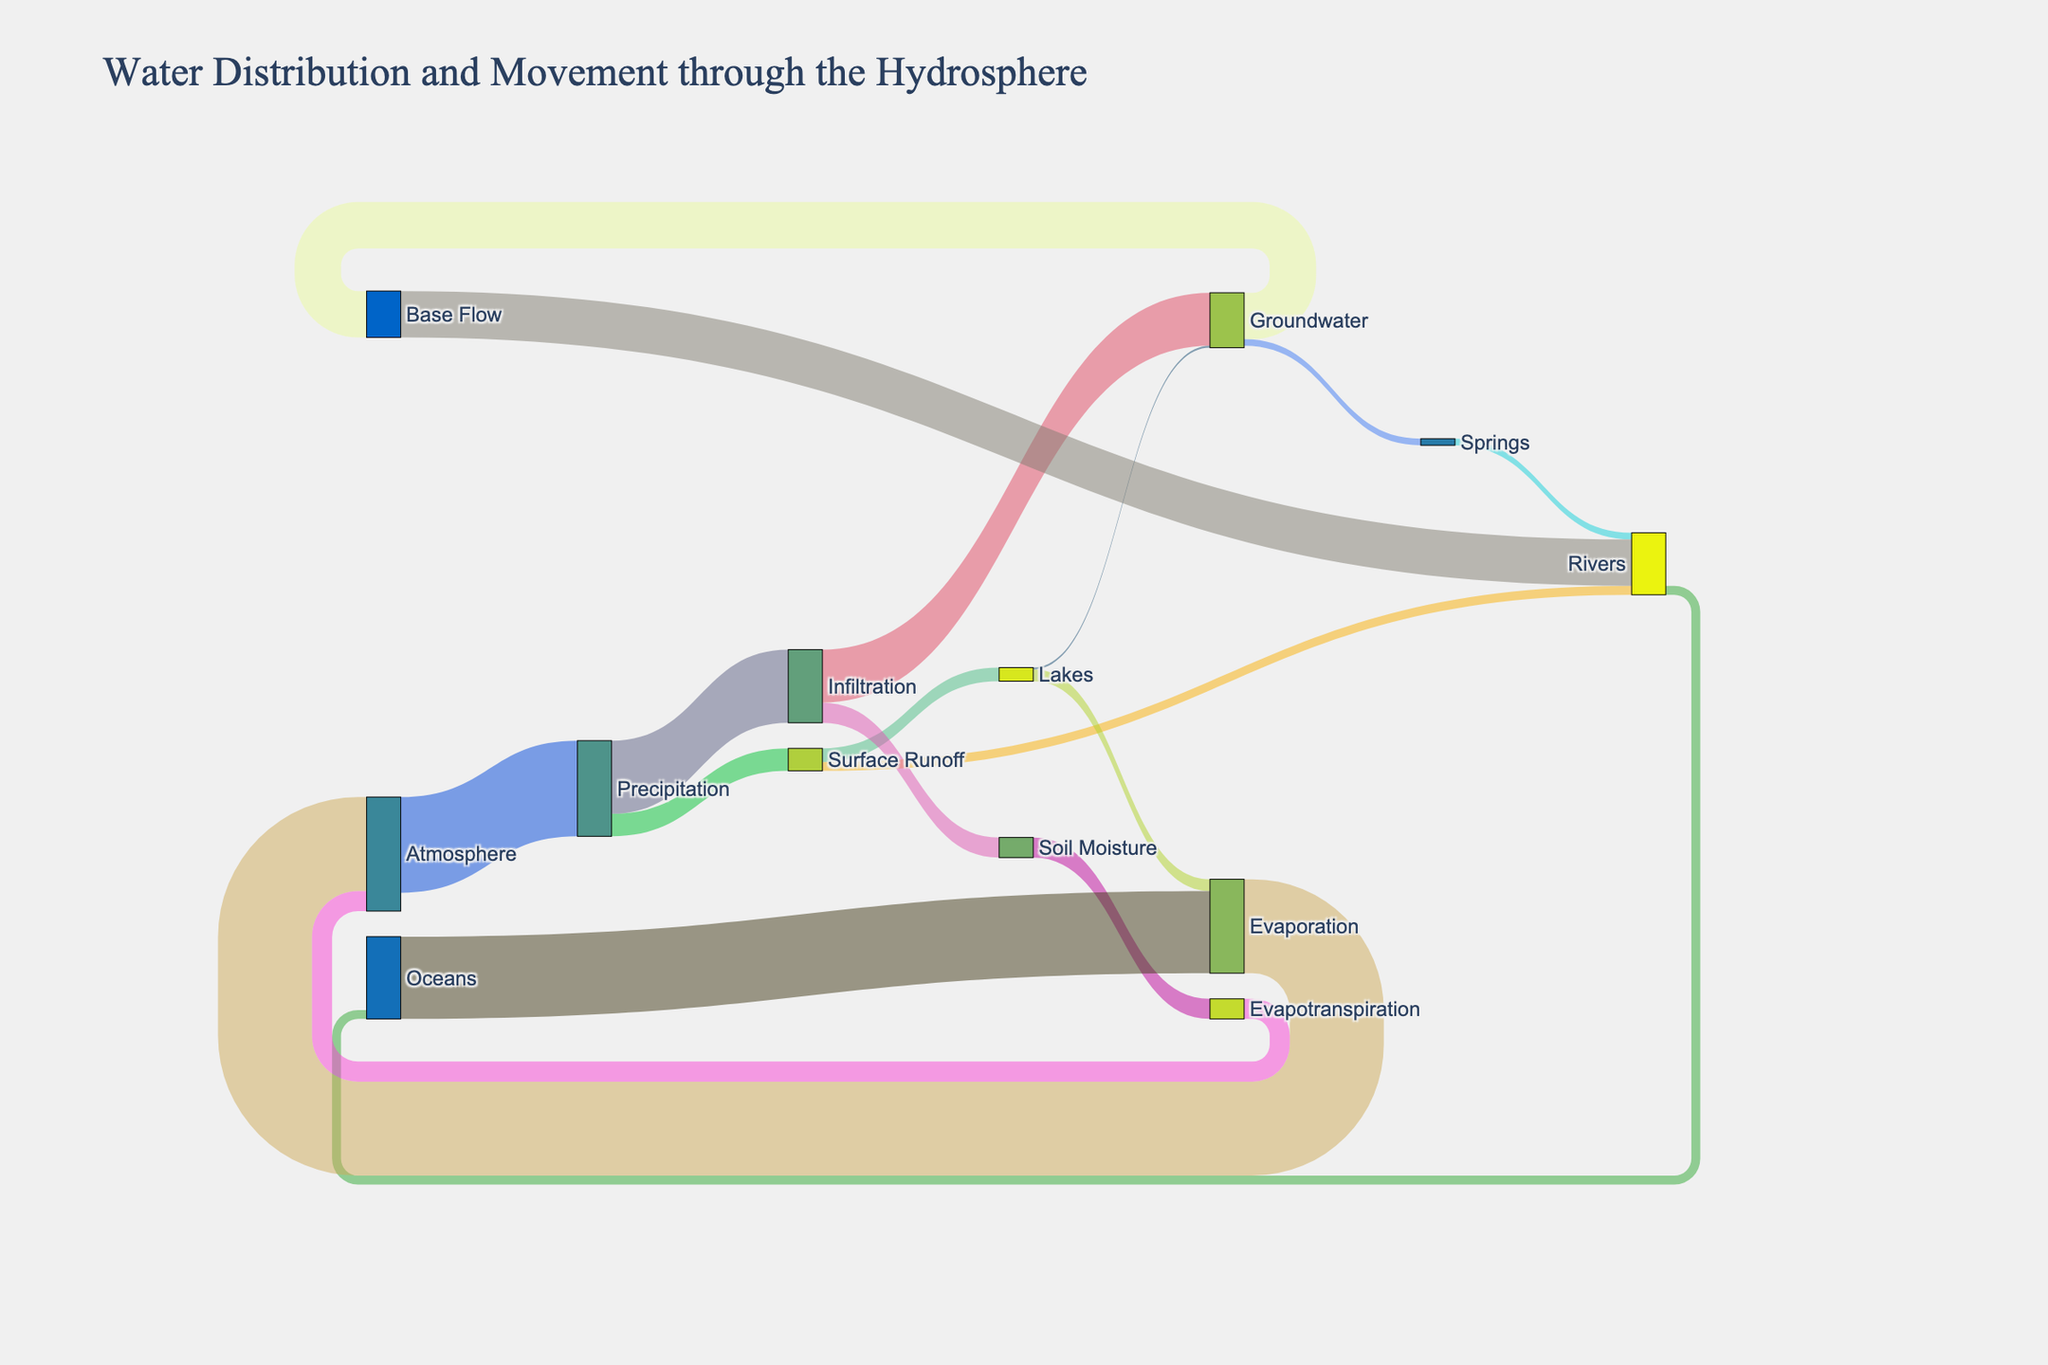What is the title of the figure? The title is usually located at the top of the figure and provides a summary of what the figure represents.
Answer: Water Distribution and Movement through the Hydrosphere How much water infiltrates into the ground from precipitation? To find this, look for the flow from "Precipitation" to "Infiltration" in the diagram.
Answer: 386,000 What is the largest water flow from the groundwater? Identify the outgoing flows from the "Groundwater" node and compare their values. The largest is "Groundwater" to "Base Flow".
Answer: 245,000 Which flow is larger: Evaporation from lakes or infiltration into the soil? Compare the flow value of "Lakes" to "Evaporation" with "Infiltration" to "Soil Moisture".
Answer: Infiltration into the soil How much water is transferred from the rivers to the oceans? Look for the flow from "Rivers" to "Oceans" on the diagram.
Answer: 47,000 Which node has the most outgoing connections? Count the outgoing connections for each node in the diagram.
Answer: Precipitation What is the total amount of water returned to the atmosphere through evaporation and evapotranspiration? Sum the values of "Evaporation" from "Oceans" and "Lakes" and "Evapotranspiration" from "Soil Moisture".
Answer: 496,000 + 106,000 = 602,000 Is there more water flowing into rivers from surface runoff or from groundwater? Compare the flow values "Surface Runoff" to "Rivers" and "Base Flow" to "Rivers".
Answer: Groundwater What happens to the majority of water from precipitation? Compare the values of flows from "Precipitation" to various targets. The majority goes to "Infiltration".
Answer: Infiltration Does soil moisture contribute back to the atmosphere? If yes, how much? Look for a flow coming from "Soil Moisture" and leading to "Atmosphere" or any process that transfers water to the atmosphere.
Answer: Yes, 106,000 